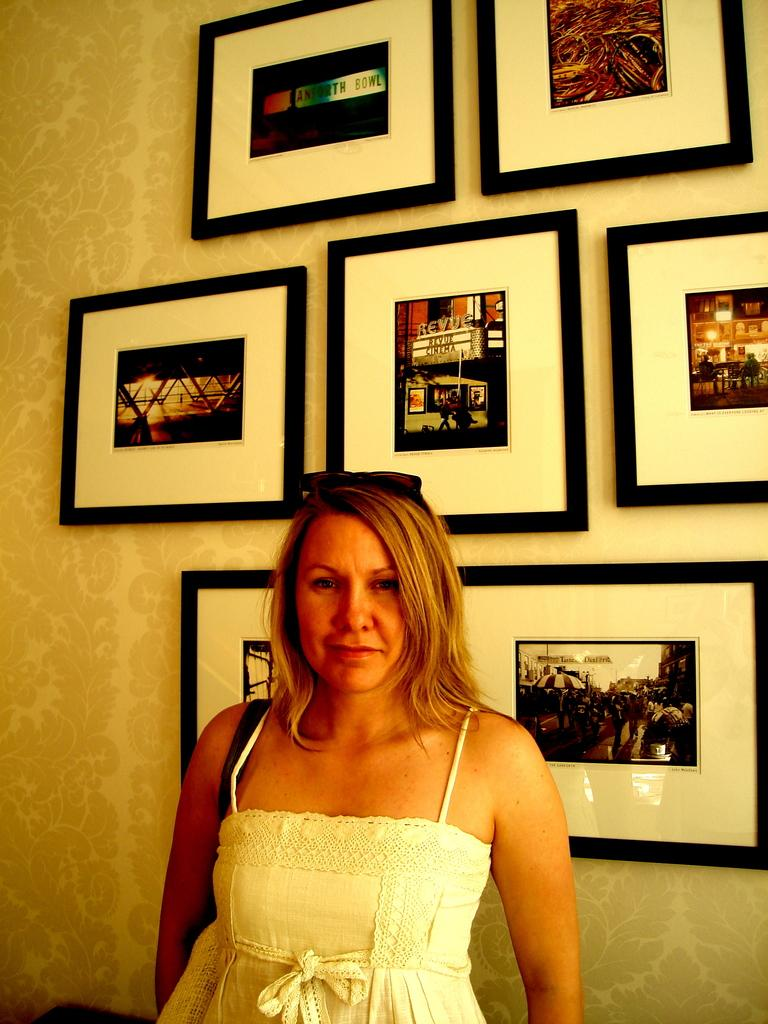Who is the main subject in the image? There is a woman in the image. What is the woman doing in the image? The woman is standing. What is the woman wearing in the image? The woman is wearing a white dress. What expression does the woman have in the image? The woman is smiling. What can be seen in the background of the image? There are photos on the wall in the background of the image. What type of body of water can be seen in the image? There is no body of water present in the image. What is the woman doing with her wrist in the image? The woman's wrist is not visible in the image, and there is no indication of any specific action involving her wrist. 